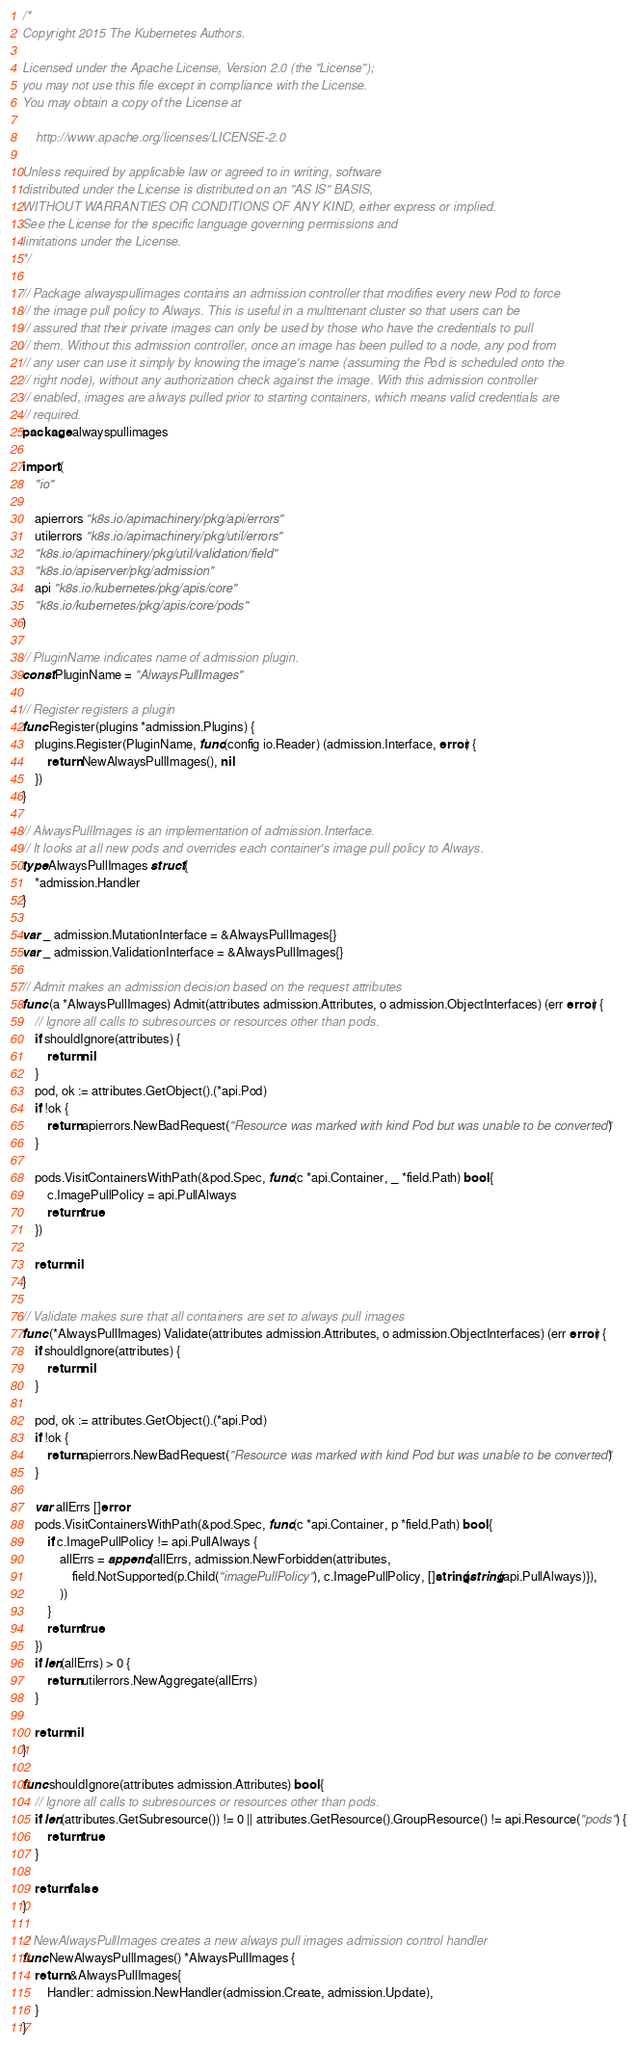Convert code to text. <code><loc_0><loc_0><loc_500><loc_500><_Go_>/*
Copyright 2015 The Kubernetes Authors.

Licensed under the Apache License, Version 2.0 (the "License");
you may not use this file except in compliance with the License.
You may obtain a copy of the License at

    http://www.apache.org/licenses/LICENSE-2.0

Unless required by applicable law or agreed to in writing, software
distributed under the License is distributed on an "AS IS" BASIS,
WITHOUT WARRANTIES OR CONDITIONS OF ANY KIND, either express or implied.
See the License for the specific language governing permissions and
limitations under the License.
*/

// Package alwayspullimages contains an admission controller that modifies every new Pod to force
// the image pull policy to Always. This is useful in a multitenant cluster so that users can be
// assured that their private images can only be used by those who have the credentials to pull
// them. Without this admission controller, once an image has been pulled to a node, any pod from
// any user can use it simply by knowing the image's name (assuming the Pod is scheduled onto the
// right node), without any authorization check against the image. With this admission controller
// enabled, images are always pulled prior to starting containers, which means valid credentials are
// required.
package alwayspullimages

import (
	"io"

	apierrors "k8s.io/apimachinery/pkg/api/errors"
	utilerrors "k8s.io/apimachinery/pkg/util/errors"
	"k8s.io/apimachinery/pkg/util/validation/field"
	"k8s.io/apiserver/pkg/admission"
	api "k8s.io/kubernetes/pkg/apis/core"
	"k8s.io/kubernetes/pkg/apis/core/pods"
)

// PluginName indicates name of admission plugin.
const PluginName = "AlwaysPullImages"

// Register registers a plugin
func Register(plugins *admission.Plugins) {
	plugins.Register(PluginName, func(config io.Reader) (admission.Interface, error) {
		return NewAlwaysPullImages(), nil
	})
}

// AlwaysPullImages is an implementation of admission.Interface.
// It looks at all new pods and overrides each container's image pull policy to Always.
type AlwaysPullImages struct {
	*admission.Handler
}

var _ admission.MutationInterface = &AlwaysPullImages{}
var _ admission.ValidationInterface = &AlwaysPullImages{}

// Admit makes an admission decision based on the request attributes
func (a *AlwaysPullImages) Admit(attributes admission.Attributes, o admission.ObjectInterfaces) (err error) {
	// Ignore all calls to subresources or resources other than pods.
	if shouldIgnore(attributes) {
		return nil
	}
	pod, ok := attributes.GetObject().(*api.Pod)
	if !ok {
		return apierrors.NewBadRequest("Resource was marked with kind Pod but was unable to be converted")
	}

	pods.VisitContainersWithPath(&pod.Spec, func(c *api.Container, _ *field.Path) bool {
		c.ImagePullPolicy = api.PullAlways
		return true
	})

	return nil
}

// Validate makes sure that all containers are set to always pull images
func (*AlwaysPullImages) Validate(attributes admission.Attributes, o admission.ObjectInterfaces) (err error) {
	if shouldIgnore(attributes) {
		return nil
	}

	pod, ok := attributes.GetObject().(*api.Pod)
	if !ok {
		return apierrors.NewBadRequest("Resource was marked with kind Pod but was unable to be converted")
	}

	var allErrs []error
	pods.VisitContainersWithPath(&pod.Spec, func(c *api.Container, p *field.Path) bool {
		if c.ImagePullPolicy != api.PullAlways {
			allErrs = append(allErrs, admission.NewForbidden(attributes,
				field.NotSupported(p.Child("imagePullPolicy"), c.ImagePullPolicy, []string{string(api.PullAlways)}),
			))
		}
		return true
	})
	if len(allErrs) > 0 {
		return utilerrors.NewAggregate(allErrs)
	}

	return nil
}

func shouldIgnore(attributes admission.Attributes) bool {
	// Ignore all calls to subresources or resources other than pods.
	if len(attributes.GetSubresource()) != 0 || attributes.GetResource().GroupResource() != api.Resource("pods") {
		return true
	}

	return false
}

// NewAlwaysPullImages creates a new always pull images admission control handler
func NewAlwaysPullImages() *AlwaysPullImages {
	return &AlwaysPullImages{
		Handler: admission.NewHandler(admission.Create, admission.Update),
	}
}
</code> 